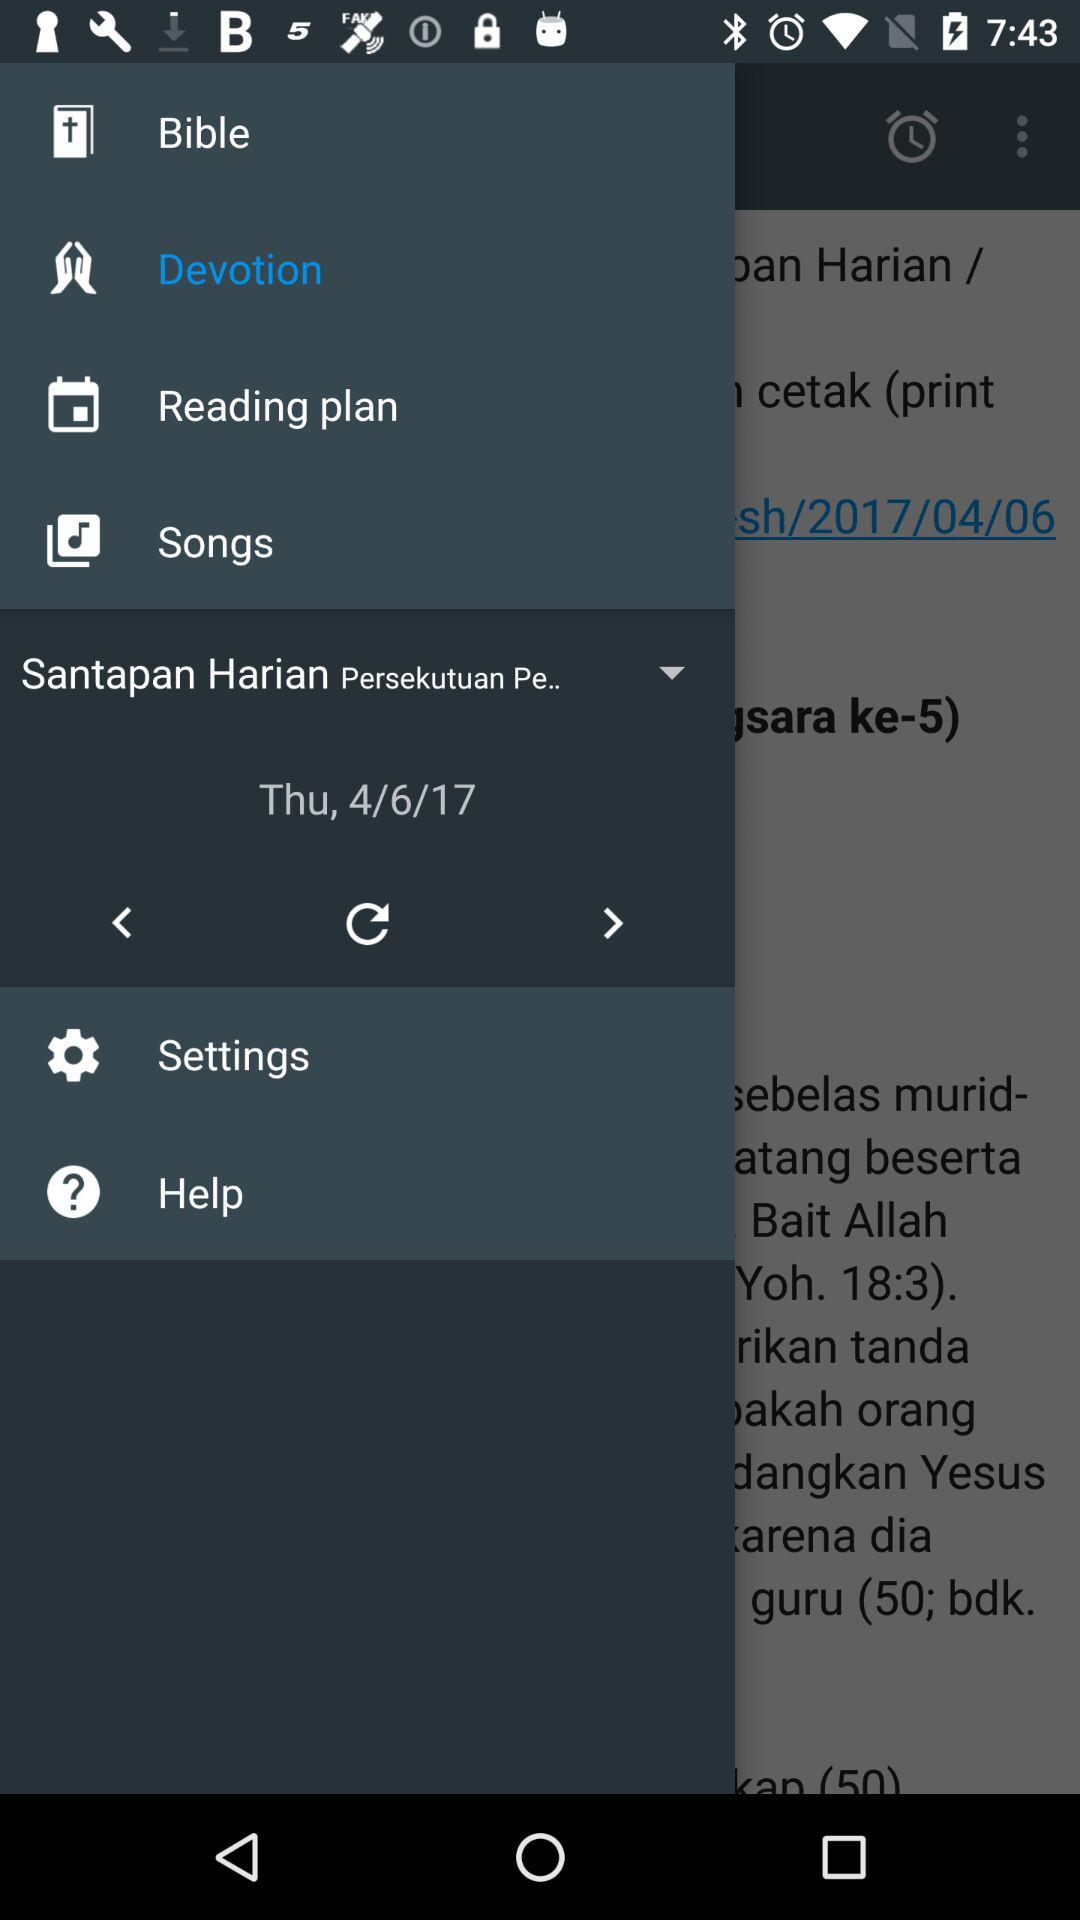What day was April 6, 2017? The day was Thursday. 